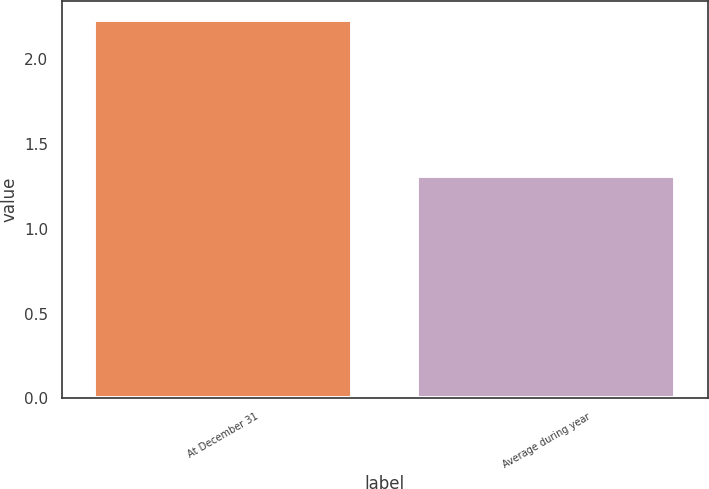Convert chart. <chart><loc_0><loc_0><loc_500><loc_500><bar_chart><fcel>At December 31<fcel>Average during year<nl><fcel>2.23<fcel>1.31<nl></chart> 